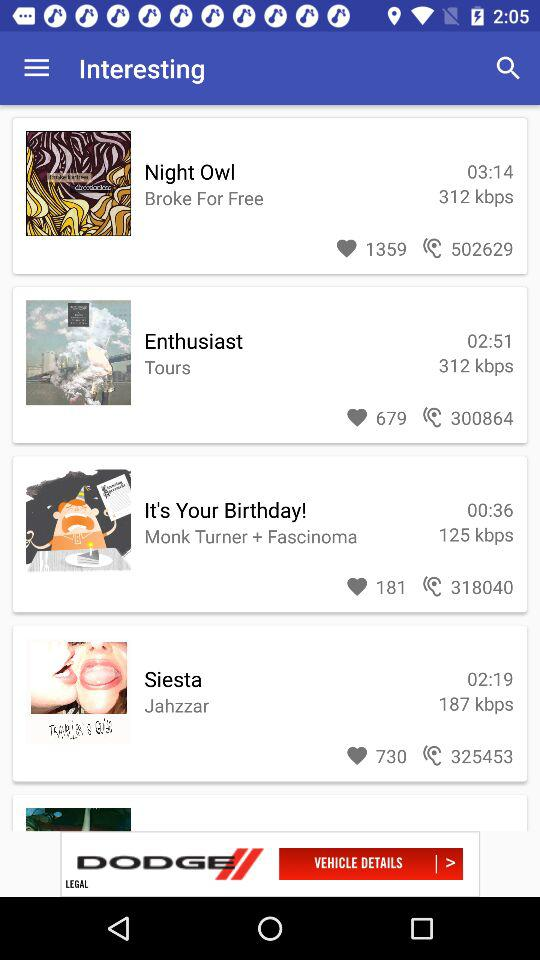What is the time duration of the "Night Owl"? The time duration is 3 minutes and 14 seconds. 